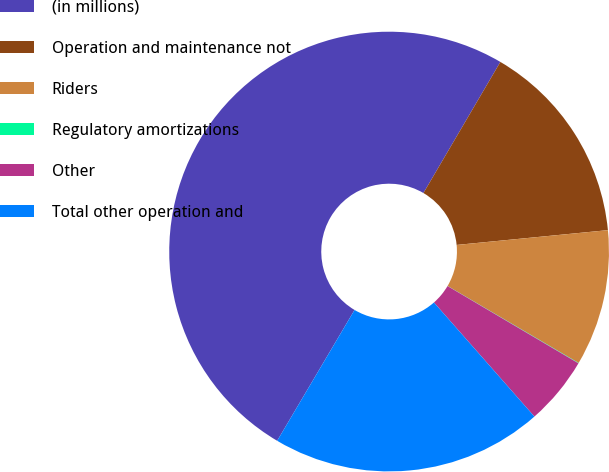Convert chart. <chart><loc_0><loc_0><loc_500><loc_500><pie_chart><fcel>(in millions)<fcel>Operation and maintenance not<fcel>Riders<fcel>Regulatory amortizations<fcel>Other<fcel>Total other operation and<nl><fcel>49.94%<fcel>15.0%<fcel>10.01%<fcel>0.03%<fcel>5.02%<fcel>19.99%<nl></chart> 